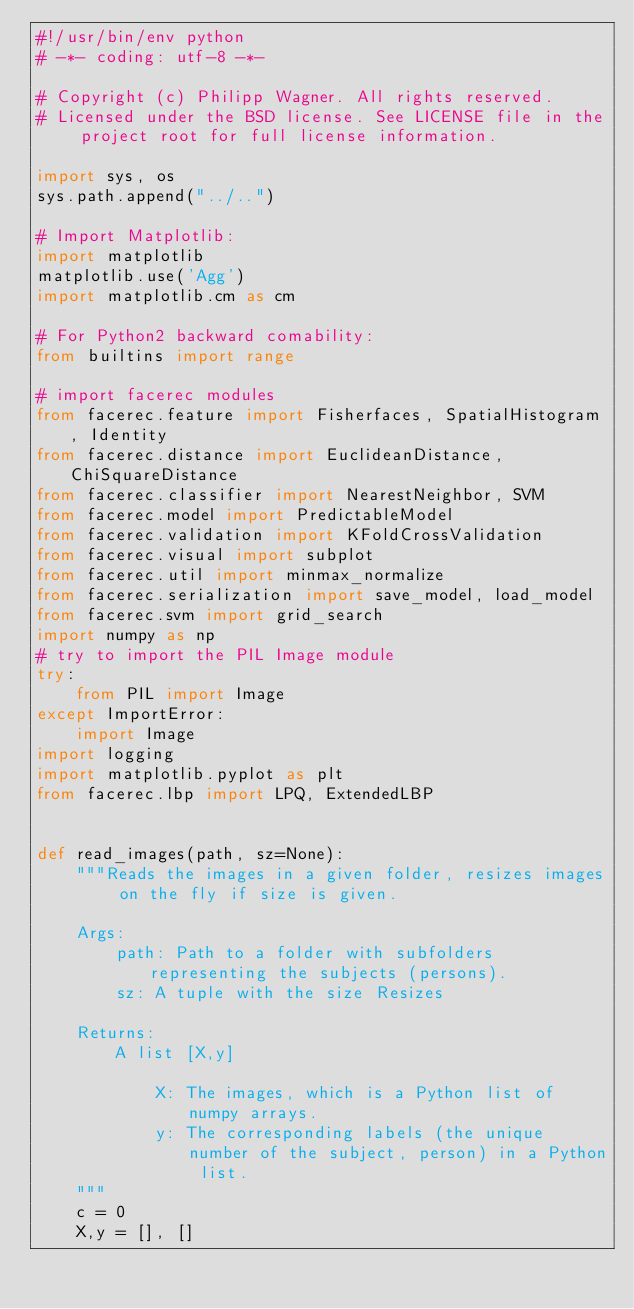<code> <loc_0><loc_0><loc_500><loc_500><_Python_>#!/usr/bin/env python
# -*- coding: utf-8 -*-

# Copyright (c) Philipp Wagner. All rights reserved.
# Licensed under the BSD license. See LICENSE file in the project root for full license information.

import sys, os
sys.path.append("../..")

# Import Matplotlib:
import matplotlib
matplotlib.use('Agg')
import matplotlib.cm as cm

# For Python2 backward comability:
from builtins import range

# import facerec modules
from facerec.feature import Fisherfaces, SpatialHistogram, Identity
from facerec.distance import EuclideanDistance, ChiSquareDistance
from facerec.classifier import NearestNeighbor, SVM
from facerec.model import PredictableModel
from facerec.validation import KFoldCrossValidation
from facerec.visual import subplot
from facerec.util import minmax_normalize
from facerec.serialization import save_model, load_model
from facerec.svm import grid_search
import numpy as np
# try to import the PIL Image module
try:
    from PIL import Image
except ImportError:
    import Image
import logging
import matplotlib.pyplot as plt
from facerec.lbp import LPQ, ExtendedLBP


def read_images(path, sz=None):
    """Reads the images in a given folder, resizes images on the fly if size is given.

    Args:
        path: Path to a folder with subfolders representing the subjects (persons).
        sz: A tuple with the size Resizes 

    Returns:
        A list [X,y]

            X: The images, which is a Python list of numpy arrays.
            y: The corresponding labels (the unique number of the subject, person) in a Python list.
    """
    c = 0
    X,y = [], []</code> 